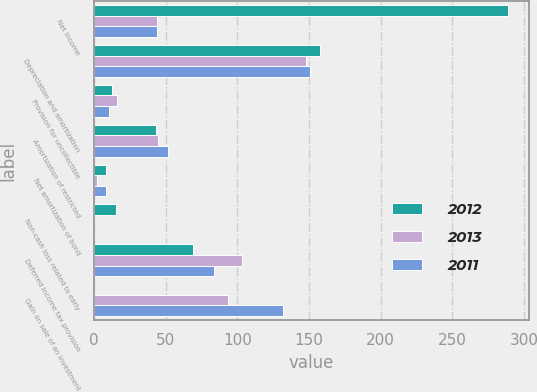<chart> <loc_0><loc_0><loc_500><loc_500><stacked_bar_chart><ecel><fcel>Net income<fcel>Depreciation and amortization<fcel>Provision for uncollectible<fcel>Amortization of restricted<fcel>Net amortization of bond<fcel>Non-cash loss related to early<fcel>Deferred income tax provision<fcel>Gain on sale of an investment<nl><fcel>2012<fcel>288.9<fcel>157.4<fcel>12.6<fcel>43.1<fcel>8.6<fcel>15.2<fcel>69.4<fcel>0<nl><fcel>2013<fcel>43.8<fcel>147.7<fcel>16.3<fcel>44.5<fcel>1.8<fcel>0<fcel>103.6<fcel>93.6<nl><fcel>2011<fcel>43.8<fcel>150.9<fcel>10.4<fcel>51.7<fcel>8.7<fcel>0<fcel>83.9<fcel>132.2<nl></chart> 